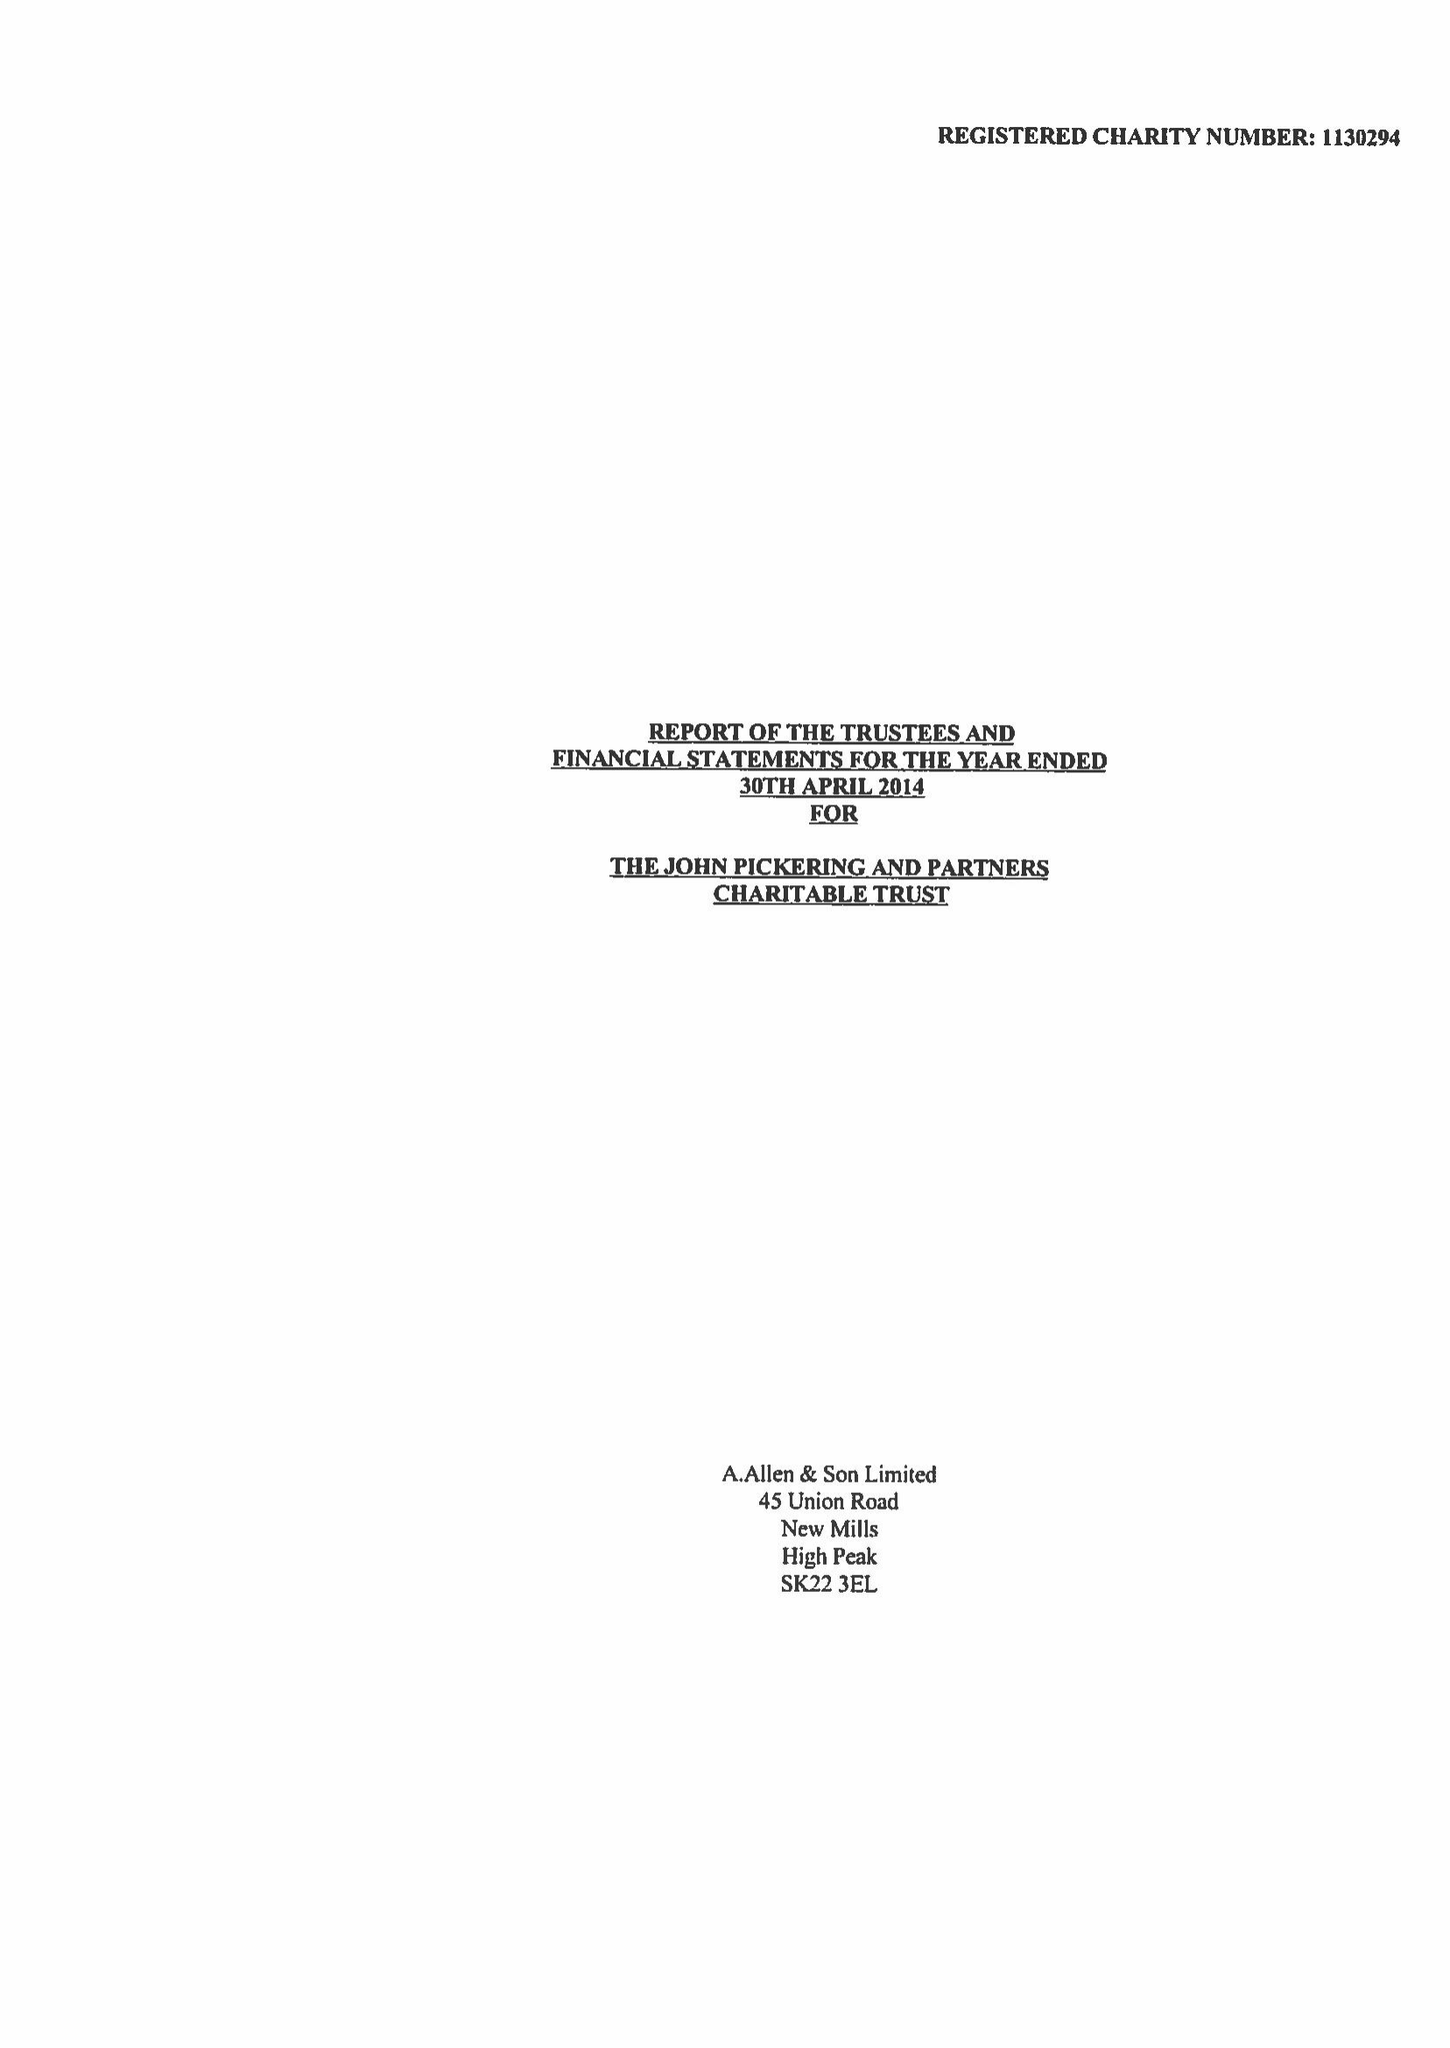What is the value for the report_date?
Answer the question using a single word or phrase. 2014-04-30 